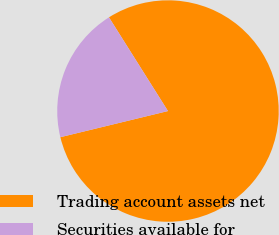<chart> <loc_0><loc_0><loc_500><loc_500><pie_chart><fcel>Trading account assets net<fcel>Securities available for<nl><fcel>80.15%<fcel>19.85%<nl></chart> 